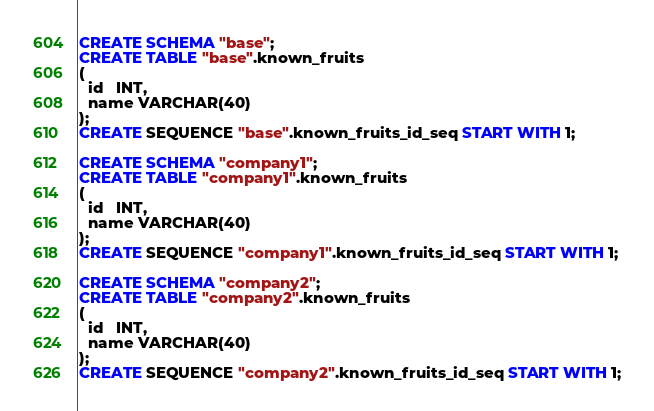<code> <loc_0><loc_0><loc_500><loc_500><_SQL_>CREATE SCHEMA "base";
CREATE TABLE "base".known_fruits
(
  id   INT,
  name VARCHAR(40)
);
CREATE SEQUENCE "base".known_fruits_id_seq START WITH 1;

CREATE SCHEMA "company1";
CREATE TABLE "company1".known_fruits
(
  id   INT,
  name VARCHAR(40)
);
CREATE SEQUENCE "company1".known_fruits_id_seq START WITH 1;

CREATE SCHEMA "company2";
CREATE TABLE "company2".known_fruits
(
  id   INT,
  name VARCHAR(40)
);
CREATE SEQUENCE "company2".known_fruits_id_seq START WITH 1;
</code> 